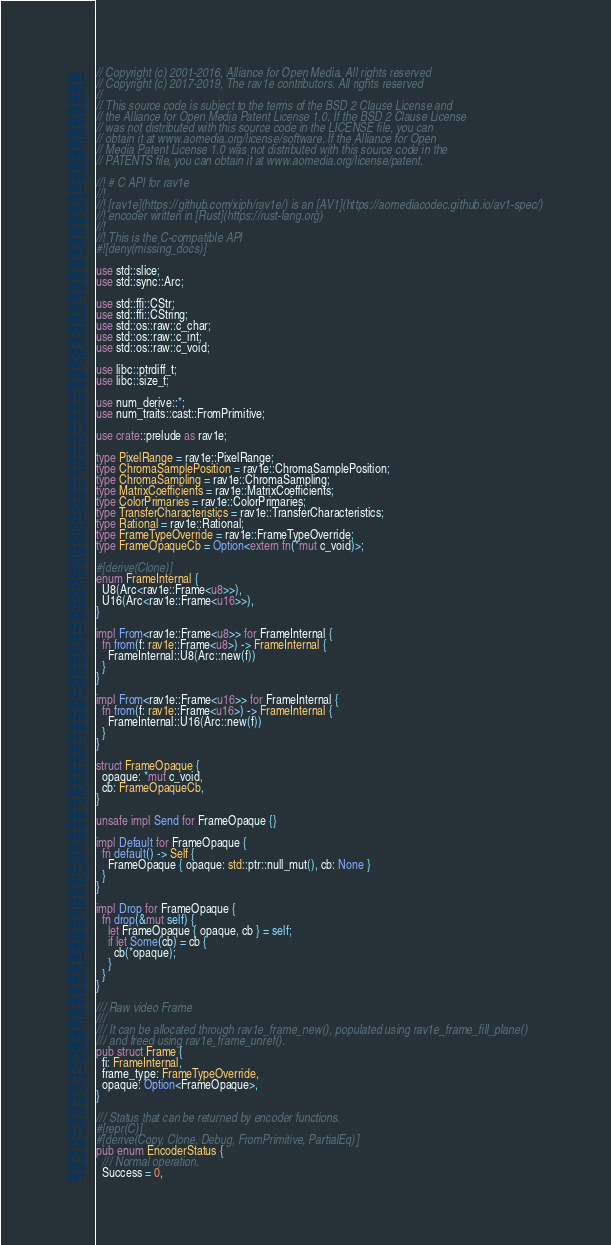<code> <loc_0><loc_0><loc_500><loc_500><_Rust_>// Copyright (c) 2001-2016, Alliance for Open Media. All rights reserved
// Copyright (c) 2017-2019, The rav1e contributors. All rights reserved
//
// This source code is subject to the terms of the BSD 2 Clause License and
// the Alliance for Open Media Patent License 1.0. If the BSD 2 Clause License
// was not distributed with this source code in the LICENSE file, you can
// obtain it at www.aomedia.org/license/software. If the Alliance for Open
// Media Patent License 1.0 was not distributed with this source code in the
// PATENTS file, you can obtain it at www.aomedia.org/license/patent.

//! # C API for rav1e
//!
//! [rav1e](https://github.com/xiph/rav1e/) is an [AV1](https://aomediacodec.github.io/av1-spec/)
//! encoder written in [Rust](https://rust-lang.org)
//!
//! This is the C-compatible API
#![deny(missing_docs)]

use std::slice;
use std::sync::Arc;

use std::ffi::CStr;
use std::ffi::CString;
use std::os::raw::c_char;
use std::os::raw::c_int;
use std::os::raw::c_void;

use libc::ptrdiff_t;
use libc::size_t;

use num_derive::*;
use num_traits::cast::FromPrimitive;

use crate::prelude as rav1e;

type PixelRange = rav1e::PixelRange;
type ChromaSamplePosition = rav1e::ChromaSamplePosition;
type ChromaSampling = rav1e::ChromaSampling;
type MatrixCoefficients = rav1e::MatrixCoefficients;
type ColorPrimaries = rav1e::ColorPrimaries;
type TransferCharacteristics = rav1e::TransferCharacteristics;
type Rational = rav1e::Rational;
type FrameTypeOverride = rav1e::FrameTypeOverride;
type FrameOpaqueCb = Option<extern fn(*mut c_void)>;

#[derive(Clone)]
enum FrameInternal {
  U8(Arc<rav1e::Frame<u8>>),
  U16(Arc<rav1e::Frame<u16>>),
}

impl From<rav1e::Frame<u8>> for FrameInternal {
  fn from(f: rav1e::Frame<u8>) -> FrameInternal {
    FrameInternal::U8(Arc::new(f))
  }
}

impl From<rav1e::Frame<u16>> for FrameInternal {
  fn from(f: rav1e::Frame<u16>) -> FrameInternal {
    FrameInternal::U16(Arc::new(f))
  }
}

struct FrameOpaque {
  opaque: *mut c_void,
  cb: FrameOpaqueCb,
}

unsafe impl Send for FrameOpaque {}

impl Default for FrameOpaque {
  fn default() -> Self {
    FrameOpaque { opaque: std::ptr::null_mut(), cb: None }
  }
}

impl Drop for FrameOpaque {
  fn drop(&mut self) {
    let FrameOpaque { opaque, cb } = self;
    if let Some(cb) = cb {
      cb(*opaque);
    }
  }
}

/// Raw video Frame
///
/// It can be allocated through rav1e_frame_new(), populated using rav1e_frame_fill_plane()
/// and freed using rav1e_frame_unref().
pub struct Frame {
  fi: FrameInternal,
  frame_type: FrameTypeOverride,
  opaque: Option<FrameOpaque>,
}

/// Status that can be returned by encoder functions.
#[repr(C)]
#[derive(Copy, Clone, Debug, FromPrimitive, PartialEq)]
pub enum EncoderStatus {
  /// Normal operation.
  Success = 0,</code> 